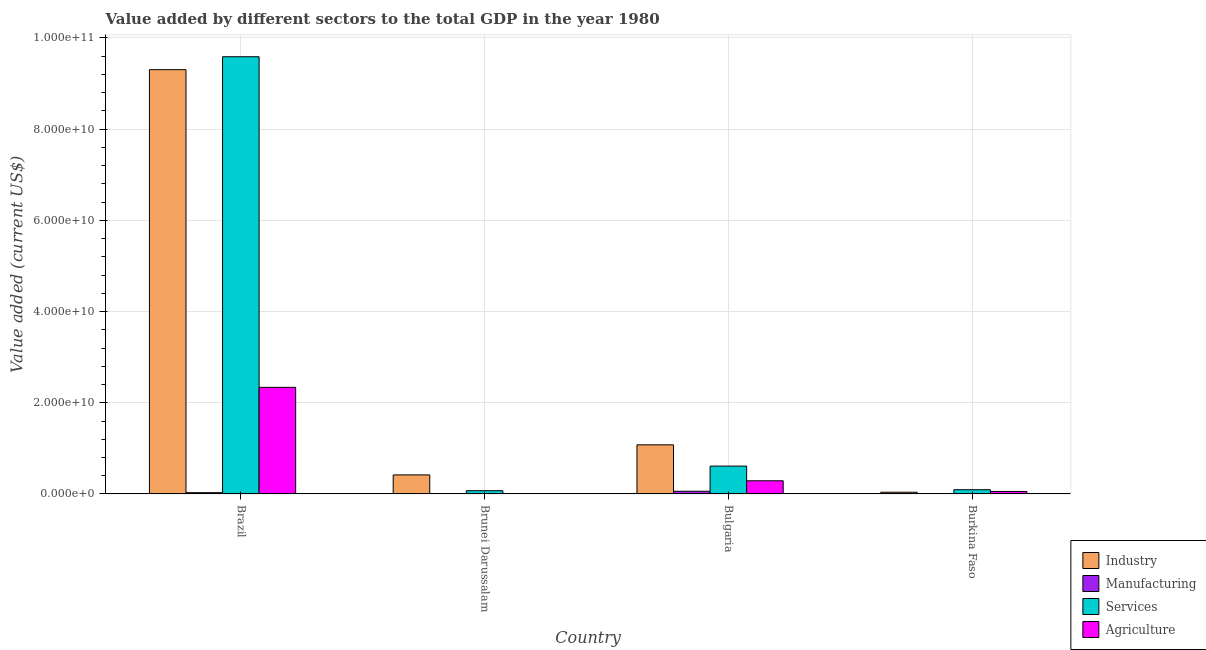Are the number of bars per tick equal to the number of legend labels?
Ensure brevity in your answer.  Yes. In how many cases, is the number of bars for a given country not equal to the number of legend labels?
Offer a terse response. 0. What is the value added by manufacturing sector in Brazil?
Ensure brevity in your answer.  2.84e+08. Across all countries, what is the maximum value added by industrial sector?
Offer a terse response. 9.31e+1. Across all countries, what is the minimum value added by industrial sector?
Ensure brevity in your answer.  3.82e+08. In which country was the value added by agricultural sector minimum?
Provide a short and direct response. Brunei Darussalam. What is the total value added by industrial sector in the graph?
Your answer should be compact. 1.08e+11. What is the difference between the value added by industrial sector in Brazil and that in Brunei Darussalam?
Your answer should be very brief. 8.89e+1. What is the difference between the value added by services sector in Brunei Darussalam and the value added by industrial sector in Burkina Faso?
Give a very brief answer. 3.35e+08. What is the average value added by agricultural sector per country?
Provide a short and direct response. 6.71e+09. What is the difference between the value added by manufacturing sector and value added by services sector in Burkina Faso?
Offer a very short reply. -8.81e+08. In how many countries, is the value added by industrial sector greater than 56000000000 US$?
Keep it short and to the point. 1. What is the ratio of the value added by agricultural sector in Brazil to that in Bulgaria?
Your response must be concise. 8.09. Is the value added by manufacturing sector in Brunei Darussalam less than that in Burkina Faso?
Your answer should be very brief. No. What is the difference between the highest and the second highest value added by industrial sector?
Give a very brief answer. 8.23e+1. What is the difference between the highest and the lowest value added by manufacturing sector?
Your response must be concise. 5.39e+08. In how many countries, is the value added by industrial sector greater than the average value added by industrial sector taken over all countries?
Provide a short and direct response. 1. Is the sum of the value added by services sector in Brunei Darussalam and Burkina Faso greater than the maximum value added by agricultural sector across all countries?
Ensure brevity in your answer.  No. What does the 4th bar from the left in Burkina Faso represents?
Your answer should be very brief. Agriculture. What does the 4th bar from the right in Bulgaria represents?
Your answer should be very brief. Industry. How many bars are there?
Offer a very short reply. 16. Are the values on the major ticks of Y-axis written in scientific E-notation?
Make the answer very short. Yes. Does the graph contain any zero values?
Give a very brief answer. No. Does the graph contain grids?
Your answer should be very brief. Yes. Where does the legend appear in the graph?
Your answer should be compact. Bottom right. How many legend labels are there?
Your answer should be compact. 4. What is the title of the graph?
Provide a short and direct response. Value added by different sectors to the total GDP in the year 1980. What is the label or title of the X-axis?
Keep it short and to the point. Country. What is the label or title of the Y-axis?
Your answer should be very brief. Value added (current US$). What is the Value added (current US$) in Industry in Brazil?
Your answer should be very brief. 9.31e+1. What is the Value added (current US$) in Manufacturing in Brazil?
Your answer should be compact. 2.84e+08. What is the Value added (current US$) of Services in Brazil?
Ensure brevity in your answer.  9.59e+1. What is the Value added (current US$) in Agriculture in Brazil?
Give a very brief answer. 2.34e+1. What is the Value added (current US$) of Industry in Brunei Darussalam?
Your response must be concise. 4.18e+09. What is the Value added (current US$) of Manufacturing in Brunei Darussalam?
Your answer should be very brief. 6.33e+07. What is the Value added (current US$) in Services in Brunei Darussalam?
Ensure brevity in your answer.  7.17e+08. What is the Value added (current US$) in Agriculture in Brunei Darussalam?
Offer a terse response. 3.13e+07. What is the Value added (current US$) of Industry in Bulgaria?
Your answer should be compact. 1.08e+1. What is the Value added (current US$) in Manufacturing in Bulgaria?
Make the answer very short. 5.93e+08. What is the Value added (current US$) in Services in Bulgaria?
Make the answer very short. 6.11e+09. What is the Value added (current US$) in Agriculture in Bulgaria?
Offer a terse response. 2.89e+09. What is the Value added (current US$) in Industry in Burkina Faso?
Make the answer very short. 3.82e+08. What is the Value added (current US$) of Manufacturing in Burkina Faso?
Give a very brief answer. 5.40e+07. What is the Value added (current US$) of Services in Burkina Faso?
Keep it short and to the point. 9.35e+08. What is the Value added (current US$) in Agriculture in Burkina Faso?
Ensure brevity in your answer.  5.49e+08. Across all countries, what is the maximum Value added (current US$) in Industry?
Your response must be concise. 9.31e+1. Across all countries, what is the maximum Value added (current US$) of Manufacturing?
Offer a very short reply. 5.93e+08. Across all countries, what is the maximum Value added (current US$) in Services?
Offer a terse response. 9.59e+1. Across all countries, what is the maximum Value added (current US$) of Agriculture?
Make the answer very short. 2.34e+1. Across all countries, what is the minimum Value added (current US$) of Industry?
Ensure brevity in your answer.  3.82e+08. Across all countries, what is the minimum Value added (current US$) in Manufacturing?
Offer a terse response. 5.40e+07. Across all countries, what is the minimum Value added (current US$) of Services?
Your answer should be very brief. 7.17e+08. Across all countries, what is the minimum Value added (current US$) in Agriculture?
Your answer should be very brief. 3.13e+07. What is the total Value added (current US$) in Industry in the graph?
Provide a succinct answer. 1.08e+11. What is the total Value added (current US$) in Manufacturing in the graph?
Offer a terse response. 9.95e+08. What is the total Value added (current US$) of Services in the graph?
Your response must be concise. 1.04e+11. What is the total Value added (current US$) in Agriculture in the graph?
Provide a succinct answer. 2.69e+1. What is the difference between the Value added (current US$) of Industry in Brazil and that in Brunei Darussalam?
Provide a short and direct response. 8.89e+1. What is the difference between the Value added (current US$) in Manufacturing in Brazil and that in Brunei Darussalam?
Keep it short and to the point. 2.21e+08. What is the difference between the Value added (current US$) in Services in Brazil and that in Brunei Darussalam?
Give a very brief answer. 9.52e+1. What is the difference between the Value added (current US$) of Agriculture in Brazil and that in Brunei Darussalam?
Give a very brief answer. 2.34e+1. What is the difference between the Value added (current US$) of Industry in Brazil and that in Bulgaria?
Offer a terse response. 8.23e+1. What is the difference between the Value added (current US$) of Manufacturing in Brazil and that in Bulgaria?
Your answer should be compact. -3.09e+08. What is the difference between the Value added (current US$) of Services in Brazil and that in Bulgaria?
Give a very brief answer. 8.98e+1. What is the difference between the Value added (current US$) of Agriculture in Brazil and that in Bulgaria?
Offer a terse response. 2.05e+1. What is the difference between the Value added (current US$) in Industry in Brazil and that in Burkina Faso?
Offer a very short reply. 9.27e+1. What is the difference between the Value added (current US$) of Manufacturing in Brazil and that in Burkina Faso?
Ensure brevity in your answer.  2.30e+08. What is the difference between the Value added (current US$) of Services in Brazil and that in Burkina Faso?
Provide a succinct answer. 9.50e+1. What is the difference between the Value added (current US$) in Agriculture in Brazil and that in Burkina Faso?
Make the answer very short. 2.28e+1. What is the difference between the Value added (current US$) of Industry in Brunei Darussalam and that in Bulgaria?
Ensure brevity in your answer.  -6.60e+09. What is the difference between the Value added (current US$) in Manufacturing in Brunei Darussalam and that in Bulgaria?
Offer a very short reply. -5.30e+08. What is the difference between the Value added (current US$) of Services in Brunei Darussalam and that in Bulgaria?
Give a very brief answer. -5.39e+09. What is the difference between the Value added (current US$) of Agriculture in Brunei Darussalam and that in Bulgaria?
Make the answer very short. -2.86e+09. What is the difference between the Value added (current US$) of Industry in Brunei Darussalam and that in Burkina Faso?
Provide a short and direct response. 3.80e+09. What is the difference between the Value added (current US$) in Manufacturing in Brunei Darussalam and that in Burkina Faso?
Provide a succinct answer. 9.33e+06. What is the difference between the Value added (current US$) in Services in Brunei Darussalam and that in Burkina Faso?
Offer a very short reply. -2.18e+08. What is the difference between the Value added (current US$) in Agriculture in Brunei Darussalam and that in Burkina Faso?
Offer a very short reply. -5.17e+08. What is the difference between the Value added (current US$) in Industry in Bulgaria and that in Burkina Faso?
Provide a succinct answer. 1.04e+1. What is the difference between the Value added (current US$) of Manufacturing in Bulgaria and that in Burkina Faso?
Your answer should be compact. 5.39e+08. What is the difference between the Value added (current US$) in Services in Bulgaria and that in Burkina Faso?
Your answer should be compact. 5.18e+09. What is the difference between the Value added (current US$) of Agriculture in Bulgaria and that in Burkina Faso?
Your response must be concise. 2.34e+09. What is the difference between the Value added (current US$) in Industry in Brazil and the Value added (current US$) in Manufacturing in Brunei Darussalam?
Your answer should be compact. 9.30e+1. What is the difference between the Value added (current US$) in Industry in Brazil and the Value added (current US$) in Services in Brunei Darussalam?
Ensure brevity in your answer.  9.23e+1. What is the difference between the Value added (current US$) in Industry in Brazil and the Value added (current US$) in Agriculture in Brunei Darussalam?
Keep it short and to the point. 9.30e+1. What is the difference between the Value added (current US$) in Manufacturing in Brazil and the Value added (current US$) in Services in Brunei Darussalam?
Ensure brevity in your answer.  -4.32e+08. What is the difference between the Value added (current US$) of Manufacturing in Brazil and the Value added (current US$) of Agriculture in Brunei Darussalam?
Give a very brief answer. 2.53e+08. What is the difference between the Value added (current US$) in Services in Brazil and the Value added (current US$) in Agriculture in Brunei Darussalam?
Keep it short and to the point. 9.59e+1. What is the difference between the Value added (current US$) in Industry in Brazil and the Value added (current US$) in Manufacturing in Bulgaria?
Provide a succinct answer. 9.25e+1. What is the difference between the Value added (current US$) of Industry in Brazil and the Value added (current US$) of Services in Bulgaria?
Your answer should be very brief. 8.69e+1. What is the difference between the Value added (current US$) of Industry in Brazil and the Value added (current US$) of Agriculture in Bulgaria?
Provide a succinct answer. 9.02e+1. What is the difference between the Value added (current US$) in Manufacturing in Brazil and the Value added (current US$) in Services in Bulgaria?
Make the answer very short. -5.83e+09. What is the difference between the Value added (current US$) in Manufacturing in Brazil and the Value added (current US$) in Agriculture in Bulgaria?
Offer a terse response. -2.61e+09. What is the difference between the Value added (current US$) in Services in Brazil and the Value added (current US$) in Agriculture in Bulgaria?
Provide a short and direct response. 9.30e+1. What is the difference between the Value added (current US$) of Industry in Brazil and the Value added (current US$) of Manufacturing in Burkina Faso?
Make the answer very short. 9.30e+1. What is the difference between the Value added (current US$) in Industry in Brazil and the Value added (current US$) in Services in Burkina Faso?
Offer a terse response. 9.21e+1. What is the difference between the Value added (current US$) in Industry in Brazil and the Value added (current US$) in Agriculture in Burkina Faso?
Your answer should be compact. 9.25e+1. What is the difference between the Value added (current US$) in Manufacturing in Brazil and the Value added (current US$) in Services in Burkina Faso?
Provide a succinct answer. -6.50e+08. What is the difference between the Value added (current US$) of Manufacturing in Brazil and the Value added (current US$) of Agriculture in Burkina Faso?
Offer a terse response. -2.64e+08. What is the difference between the Value added (current US$) in Services in Brazil and the Value added (current US$) in Agriculture in Burkina Faso?
Give a very brief answer. 9.53e+1. What is the difference between the Value added (current US$) in Industry in Brunei Darussalam and the Value added (current US$) in Manufacturing in Bulgaria?
Ensure brevity in your answer.  3.59e+09. What is the difference between the Value added (current US$) of Industry in Brunei Darussalam and the Value added (current US$) of Services in Bulgaria?
Offer a terse response. -1.93e+09. What is the difference between the Value added (current US$) in Industry in Brunei Darussalam and the Value added (current US$) in Agriculture in Bulgaria?
Offer a very short reply. 1.29e+09. What is the difference between the Value added (current US$) in Manufacturing in Brunei Darussalam and the Value added (current US$) in Services in Bulgaria?
Your answer should be very brief. -6.05e+09. What is the difference between the Value added (current US$) in Manufacturing in Brunei Darussalam and the Value added (current US$) in Agriculture in Bulgaria?
Provide a succinct answer. -2.83e+09. What is the difference between the Value added (current US$) of Services in Brunei Darussalam and the Value added (current US$) of Agriculture in Bulgaria?
Your answer should be compact. -2.17e+09. What is the difference between the Value added (current US$) of Industry in Brunei Darussalam and the Value added (current US$) of Manufacturing in Burkina Faso?
Your answer should be very brief. 4.13e+09. What is the difference between the Value added (current US$) in Industry in Brunei Darussalam and the Value added (current US$) in Services in Burkina Faso?
Your answer should be very brief. 3.25e+09. What is the difference between the Value added (current US$) in Industry in Brunei Darussalam and the Value added (current US$) in Agriculture in Burkina Faso?
Provide a succinct answer. 3.63e+09. What is the difference between the Value added (current US$) in Manufacturing in Brunei Darussalam and the Value added (current US$) in Services in Burkina Faso?
Ensure brevity in your answer.  -8.71e+08. What is the difference between the Value added (current US$) in Manufacturing in Brunei Darussalam and the Value added (current US$) in Agriculture in Burkina Faso?
Offer a very short reply. -4.85e+08. What is the difference between the Value added (current US$) in Services in Brunei Darussalam and the Value added (current US$) in Agriculture in Burkina Faso?
Offer a very short reply. 1.68e+08. What is the difference between the Value added (current US$) of Industry in Bulgaria and the Value added (current US$) of Manufacturing in Burkina Faso?
Your answer should be very brief. 1.07e+1. What is the difference between the Value added (current US$) in Industry in Bulgaria and the Value added (current US$) in Services in Burkina Faso?
Give a very brief answer. 9.84e+09. What is the difference between the Value added (current US$) in Industry in Bulgaria and the Value added (current US$) in Agriculture in Burkina Faso?
Offer a terse response. 1.02e+1. What is the difference between the Value added (current US$) of Manufacturing in Bulgaria and the Value added (current US$) of Services in Burkina Faso?
Give a very brief answer. -3.42e+08. What is the difference between the Value added (current US$) in Manufacturing in Bulgaria and the Value added (current US$) in Agriculture in Burkina Faso?
Your answer should be compact. 4.45e+07. What is the difference between the Value added (current US$) of Services in Bulgaria and the Value added (current US$) of Agriculture in Burkina Faso?
Make the answer very short. 5.56e+09. What is the average Value added (current US$) in Industry per country?
Offer a very short reply. 2.71e+1. What is the average Value added (current US$) in Manufacturing per country?
Give a very brief answer. 2.49e+08. What is the average Value added (current US$) of Services per country?
Your answer should be compact. 2.59e+1. What is the average Value added (current US$) of Agriculture per country?
Offer a very short reply. 6.71e+09. What is the difference between the Value added (current US$) of Industry and Value added (current US$) of Manufacturing in Brazil?
Provide a succinct answer. 9.28e+1. What is the difference between the Value added (current US$) in Industry and Value added (current US$) in Services in Brazil?
Give a very brief answer. -2.84e+09. What is the difference between the Value added (current US$) of Industry and Value added (current US$) of Agriculture in Brazil?
Provide a short and direct response. 6.97e+1. What is the difference between the Value added (current US$) of Manufacturing and Value added (current US$) of Services in Brazil?
Provide a succinct answer. -9.56e+1. What is the difference between the Value added (current US$) of Manufacturing and Value added (current US$) of Agriculture in Brazil?
Your answer should be compact. -2.31e+1. What is the difference between the Value added (current US$) of Services and Value added (current US$) of Agriculture in Brazil?
Your response must be concise. 7.25e+1. What is the difference between the Value added (current US$) in Industry and Value added (current US$) in Manufacturing in Brunei Darussalam?
Provide a short and direct response. 4.12e+09. What is the difference between the Value added (current US$) in Industry and Value added (current US$) in Services in Brunei Darussalam?
Your answer should be very brief. 3.46e+09. What is the difference between the Value added (current US$) in Industry and Value added (current US$) in Agriculture in Brunei Darussalam?
Your answer should be very brief. 4.15e+09. What is the difference between the Value added (current US$) of Manufacturing and Value added (current US$) of Services in Brunei Darussalam?
Offer a terse response. -6.53e+08. What is the difference between the Value added (current US$) in Manufacturing and Value added (current US$) in Agriculture in Brunei Darussalam?
Your response must be concise. 3.20e+07. What is the difference between the Value added (current US$) in Services and Value added (current US$) in Agriculture in Brunei Darussalam?
Make the answer very short. 6.85e+08. What is the difference between the Value added (current US$) of Industry and Value added (current US$) of Manufacturing in Bulgaria?
Your response must be concise. 1.02e+1. What is the difference between the Value added (current US$) of Industry and Value added (current US$) of Services in Bulgaria?
Give a very brief answer. 4.67e+09. What is the difference between the Value added (current US$) in Industry and Value added (current US$) in Agriculture in Bulgaria?
Your answer should be very brief. 7.89e+09. What is the difference between the Value added (current US$) of Manufacturing and Value added (current US$) of Services in Bulgaria?
Keep it short and to the point. -5.52e+09. What is the difference between the Value added (current US$) in Manufacturing and Value added (current US$) in Agriculture in Bulgaria?
Provide a succinct answer. -2.30e+09. What is the difference between the Value added (current US$) of Services and Value added (current US$) of Agriculture in Bulgaria?
Keep it short and to the point. 3.22e+09. What is the difference between the Value added (current US$) of Industry and Value added (current US$) of Manufacturing in Burkina Faso?
Your answer should be compact. 3.28e+08. What is the difference between the Value added (current US$) of Industry and Value added (current US$) of Services in Burkina Faso?
Your answer should be compact. -5.53e+08. What is the difference between the Value added (current US$) in Industry and Value added (current US$) in Agriculture in Burkina Faso?
Make the answer very short. -1.67e+08. What is the difference between the Value added (current US$) of Manufacturing and Value added (current US$) of Services in Burkina Faso?
Provide a succinct answer. -8.81e+08. What is the difference between the Value added (current US$) in Manufacturing and Value added (current US$) in Agriculture in Burkina Faso?
Offer a terse response. -4.95e+08. What is the difference between the Value added (current US$) of Services and Value added (current US$) of Agriculture in Burkina Faso?
Offer a very short reply. 3.86e+08. What is the ratio of the Value added (current US$) of Industry in Brazil to that in Brunei Darussalam?
Provide a succinct answer. 22.26. What is the ratio of the Value added (current US$) in Manufacturing in Brazil to that in Brunei Darussalam?
Make the answer very short. 4.49. What is the ratio of the Value added (current US$) of Services in Brazil to that in Brunei Darussalam?
Offer a terse response. 133.79. What is the ratio of the Value added (current US$) in Agriculture in Brazil to that in Brunei Darussalam?
Your response must be concise. 747.34. What is the ratio of the Value added (current US$) of Industry in Brazil to that in Bulgaria?
Make the answer very short. 8.64. What is the ratio of the Value added (current US$) in Manufacturing in Brazil to that in Bulgaria?
Keep it short and to the point. 0.48. What is the ratio of the Value added (current US$) in Services in Brazil to that in Bulgaria?
Your answer should be very brief. 15.69. What is the ratio of the Value added (current US$) in Agriculture in Brazil to that in Bulgaria?
Offer a terse response. 8.09. What is the ratio of the Value added (current US$) of Industry in Brazil to that in Burkina Faso?
Ensure brevity in your answer.  243.53. What is the ratio of the Value added (current US$) in Manufacturing in Brazil to that in Burkina Faso?
Your answer should be very brief. 5.27. What is the ratio of the Value added (current US$) in Services in Brazil to that in Burkina Faso?
Ensure brevity in your answer.  102.58. What is the ratio of the Value added (current US$) in Agriculture in Brazil to that in Burkina Faso?
Make the answer very short. 42.62. What is the ratio of the Value added (current US$) of Industry in Brunei Darussalam to that in Bulgaria?
Offer a very short reply. 0.39. What is the ratio of the Value added (current US$) of Manufacturing in Brunei Darussalam to that in Bulgaria?
Make the answer very short. 0.11. What is the ratio of the Value added (current US$) in Services in Brunei Darussalam to that in Bulgaria?
Give a very brief answer. 0.12. What is the ratio of the Value added (current US$) in Agriculture in Brunei Darussalam to that in Bulgaria?
Offer a terse response. 0.01. What is the ratio of the Value added (current US$) of Industry in Brunei Darussalam to that in Burkina Faso?
Offer a very short reply. 10.94. What is the ratio of the Value added (current US$) of Manufacturing in Brunei Darussalam to that in Burkina Faso?
Offer a very short reply. 1.17. What is the ratio of the Value added (current US$) in Services in Brunei Darussalam to that in Burkina Faso?
Ensure brevity in your answer.  0.77. What is the ratio of the Value added (current US$) of Agriculture in Brunei Darussalam to that in Burkina Faso?
Your answer should be compact. 0.06. What is the ratio of the Value added (current US$) of Industry in Bulgaria to that in Burkina Faso?
Your answer should be very brief. 28.2. What is the ratio of the Value added (current US$) of Manufacturing in Bulgaria to that in Burkina Faso?
Provide a short and direct response. 10.99. What is the ratio of the Value added (current US$) of Services in Bulgaria to that in Burkina Faso?
Your answer should be compact. 6.54. What is the ratio of the Value added (current US$) in Agriculture in Bulgaria to that in Burkina Faso?
Provide a succinct answer. 5.27. What is the difference between the highest and the second highest Value added (current US$) of Industry?
Ensure brevity in your answer.  8.23e+1. What is the difference between the highest and the second highest Value added (current US$) of Manufacturing?
Offer a terse response. 3.09e+08. What is the difference between the highest and the second highest Value added (current US$) of Services?
Offer a very short reply. 8.98e+1. What is the difference between the highest and the second highest Value added (current US$) of Agriculture?
Ensure brevity in your answer.  2.05e+1. What is the difference between the highest and the lowest Value added (current US$) of Industry?
Offer a terse response. 9.27e+1. What is the difference between the highest and the lowest Value added (current US$) of Manufacturing?
Provide a succinct answer. 5.39e+08. What is the difference between the highest and the lowest Value added (current US$) of Services?
Your response must be concise. 9.52e+1. What is the difference between the highest and the lowest Value added (current US$) in Agriculture?
Provide a short and direct response. 2.34e+1. 